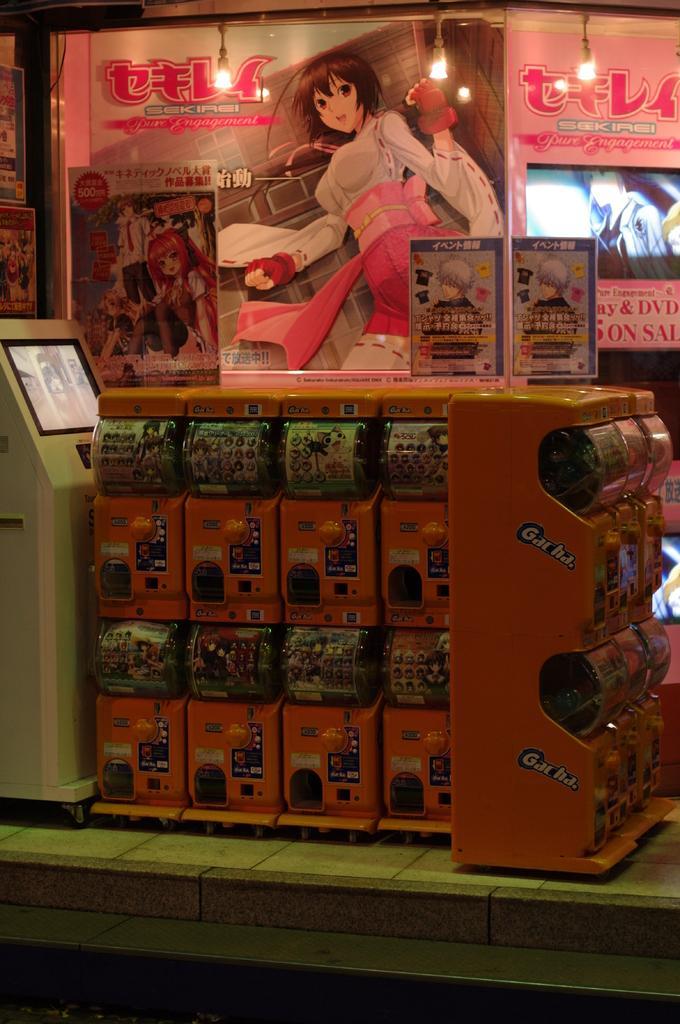How would you summarize this image in a sentence or two? In this image, we can see some shelves with objects. We can also see a white colored machine on the left. We can see some boards with text and image. We can see some lights. We can see the ground. 